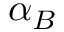<formula> <loc_0><loc_0><loc_500><loc_500>\alpha _ { B }</formula> 